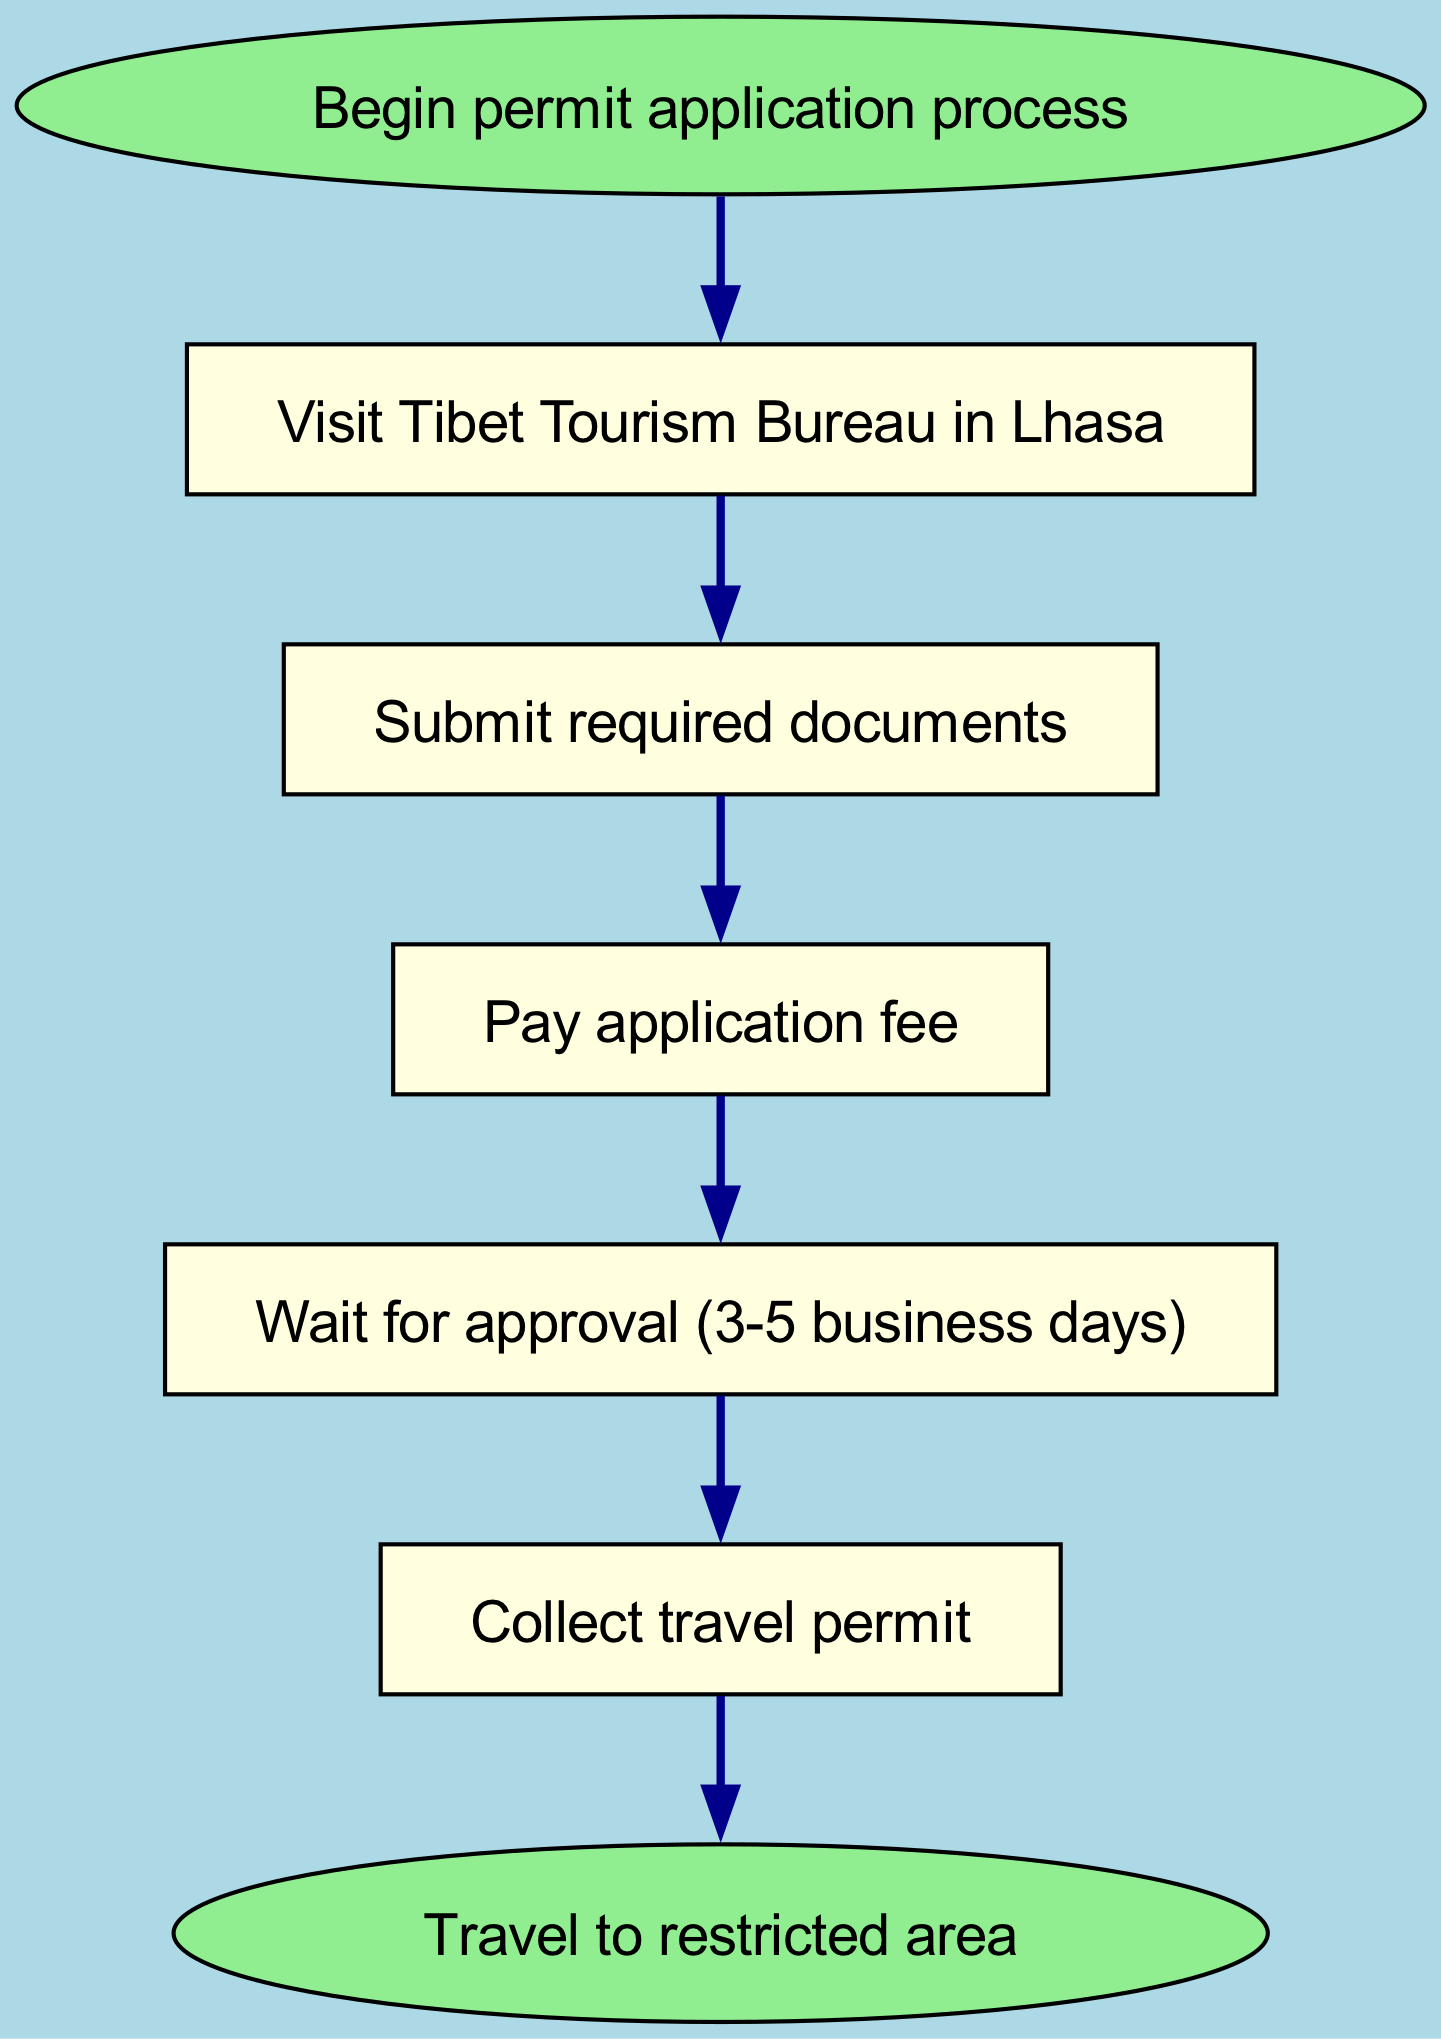What is the first step in the permit application process? The diagram indicates that the first step is labeled as "Visit Tibet Tourism Bureau in Lhasa." This is the information displayed in the first node following the start node.
Answer: Visit Tibet Tourism Bureau in Lhasa How many steps are there in total? Counting the nodes in the diagram including the start and end, there are six steps: one start node, five action nodes, and one end node. Thus, the total is 6 steps.
Answer: 6 What must be submitted after visiting the Bureau? The diagram shows that after visiting the Tibet Tourism Bureau, the next step is to "Submit required documents," which is the content of the second node.
Answer: Submit required documents How long do you need to wait for approval? According to the diagram, the node corresponding to waiting for approval states "Wait for approval (3-5 business days)," which provides the specific duration for this step.
Answer: 3-5 business days What do you collect after waiting for approval? The diagram states that the step that follows the waiting period is to "Collect travel permit," which clearly indicates the action to be taken after waiting.
Answer: Collect travel permit What is the final destination after obtaining the permit? The end node of the diagram shows that the final outcome of the process is to "Travel to restricted area," thus indicating the primary objective after the entire permit application process.
Answer: Travel to restricted area What is the relationship between submitting documents and paying the application fee? The diagram shows a direct connection from the "Submit required documents" step to the "Pay application fee" step, indicating that submitting documents is a prerequisite before paying the fee.
Answer: Prerequisite Is there a step that occurs before paying the application fee? Yes, the diagram indicates that one must "Submit required documents" before proceeding to "Pay application fee," reflecting the sequence of actions required for the application process.
Answer: Yes What color represents the start and end nodes? The diagram specifies that both the start and end nodes are colored light green, distinguishing these key points in the application flow.
Answer: Light green 